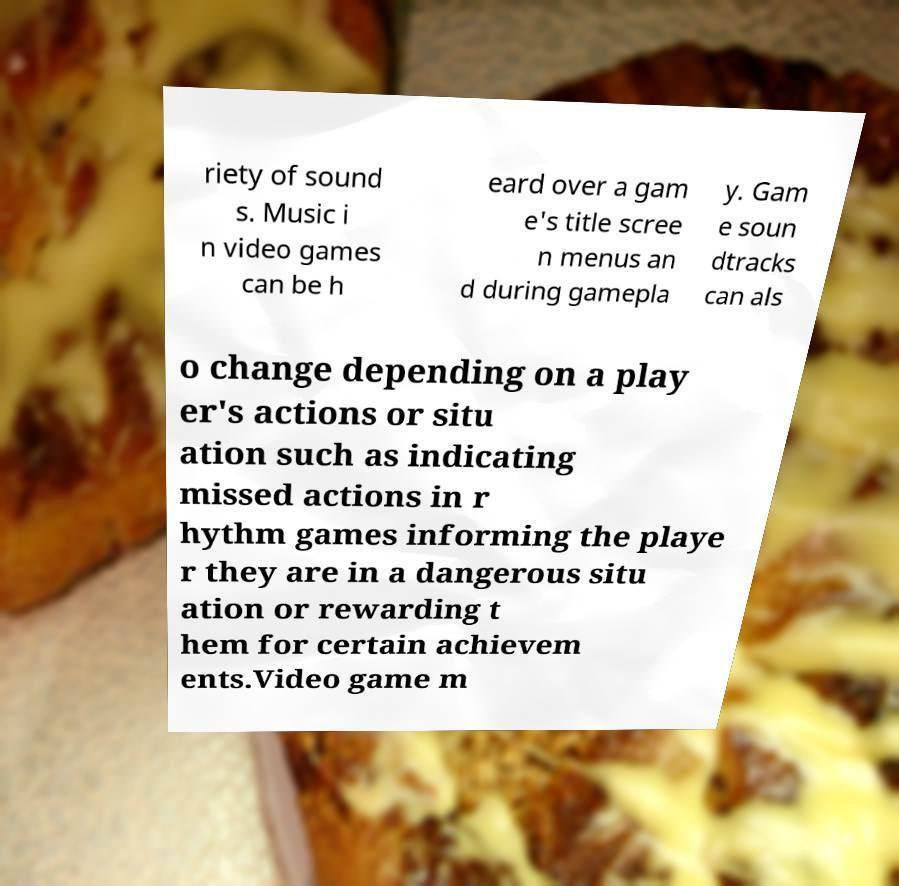Can you accurately transcribe the text from the provided image for me? riety of sound s. Music i n video games can be h eard over a gam e's title scree n menus an d during gamepla y. Gam e soun dtracks can als o change depending on a play er's actions or situ ation such as indicating missed actions in r hythm games informing the playe r they are in a dangerous situ ation or rewarding t hem for certain achievem ents.Video game m 